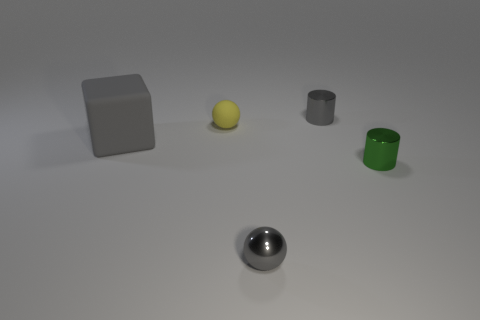What time of day do you think it is in this scene? The scene does not provide any direct indicators of the time of day, as it seems to be an indoor setup with controlled lighting. The consistent and soft shadows suggest an artificial light source, which obscures any indication of natural light or time of day. 